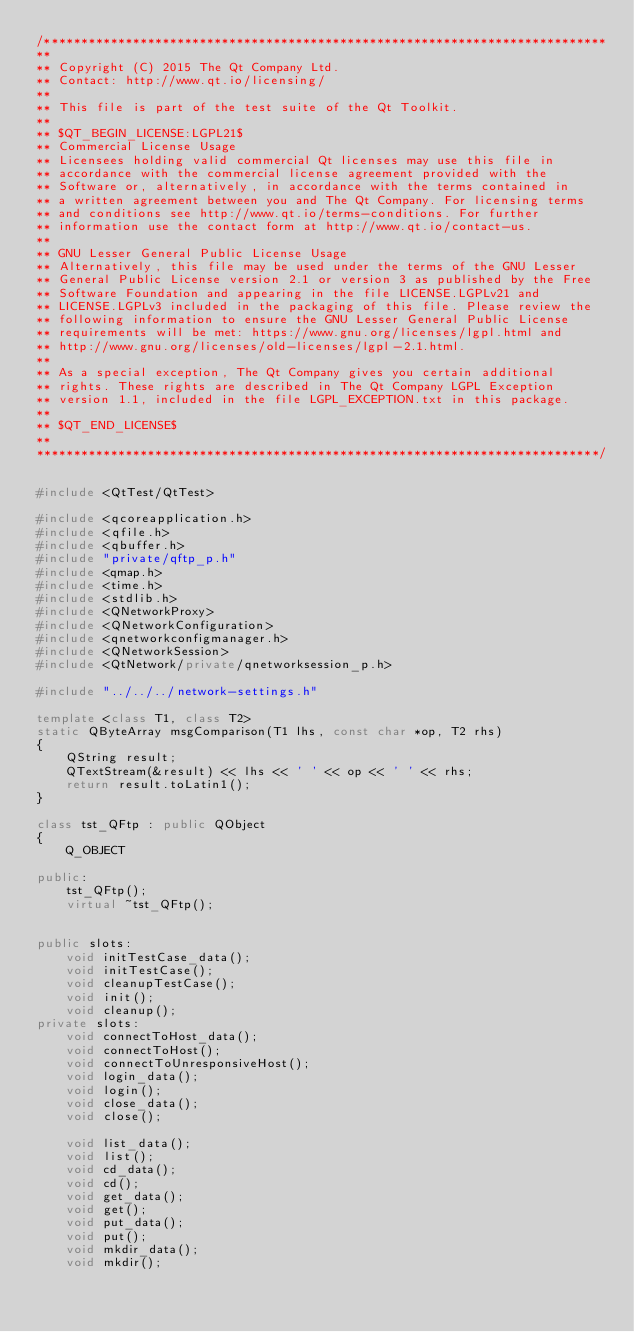Convert code to text. <code><loc_0><loc_0><loc_500><loc_500><_C++_>/****************************************************************************
**
** Copyright (C) 2015 The Qt Company Ltd.
** Contact: http://www.qt.io/licensing/
**
** This file is part of the test suite of the Qt Toolkit.
**
** $QT_BEGIN_LICENSE:LGPL21$
** Commercial License Usage
** Licensees holding valid commercial Qt licenses may use this file in
** accordance with the commercial license agreement provided with the
** Software or, alternatively, in accordance with the terms contained in
** a written agreement between you and The Qt Company. For licensing terms
** and conditions see http://www.qt.io/terms-conditions. For further
** information use the contact form at http://www.qt.io/contact-us.
**
** GNU Lesser General Public License Usage
** Alternatively, this file may be used under the terms of the GNU Lesser
** General Public License version 2.1 or version 3 as published by the Free
** Software Foundation and appearing in the file LICENSE.LGPLv21 and
** LICENSE.LGPLv3 included in the packaging of this file. Please review the
** following information to ensure the GNU Lesser General Public License
** requirements will be met: https://www.gnu.org/licenses/lgpl.html and
** http://www.gnu.org/licenses/old-licenses/lgpl-2.1.html.
**
** As a special exception, The Qt Company gives you certain additional
** rights. These rights are described in The Qt Company LGPL Exception
** version 1.1, included in the file LGPL_EXCEPTION.txt in this package.
**
** $QT_END_LICENSE$
**
****************************************************************************/


#include <QtTest/QtTest>

#include <qcoreapplication.h>
#include <qfile.h>
#include <qbuffer.h>
#include "private/qftp_p.h"
#include <qmap.h>
#include <time.h>
#include <stdlib.h>
#include <QNetworkProxy>
#include <QNetworkConfiguration>
#include <qnetworkconfigmanager.h>
#include <QNetworkSession>
#include <QtNetwork/private/qnetworksession_p.h>

#include "../../../network-settings.h"

template <class T1, class T2>
static QByteArray msgComparison(T1 lhs, const char *op, T2 rhs)
{
    QString result;
    QTextStream(&result) << lhs << ' ' << op << ' ' << rhs;
    return result.toLatin1();
}

class tst_QFtp : public QObject
{
    Q_OBJECT

public:
    tst_QFtp();
    virtual ~tst_QFtp();


public slots:
    void initTestCase_data();
    void initTestCase();
    void cleanupTestCase();
    void init();
    void cleanup();
private slots:
    void connectToHost_data();
    void connectToHost();
    void connectToUnresponsiveHost();
    void login_data();
    void login();
    void close_data();
    void close();

    void list_data();
    void list();
    void cd_data();
    void cd();
    void get_data();
    void get();
    void put_data();
    void put();
    void mkdir_data();
    void mkdir();</code> 